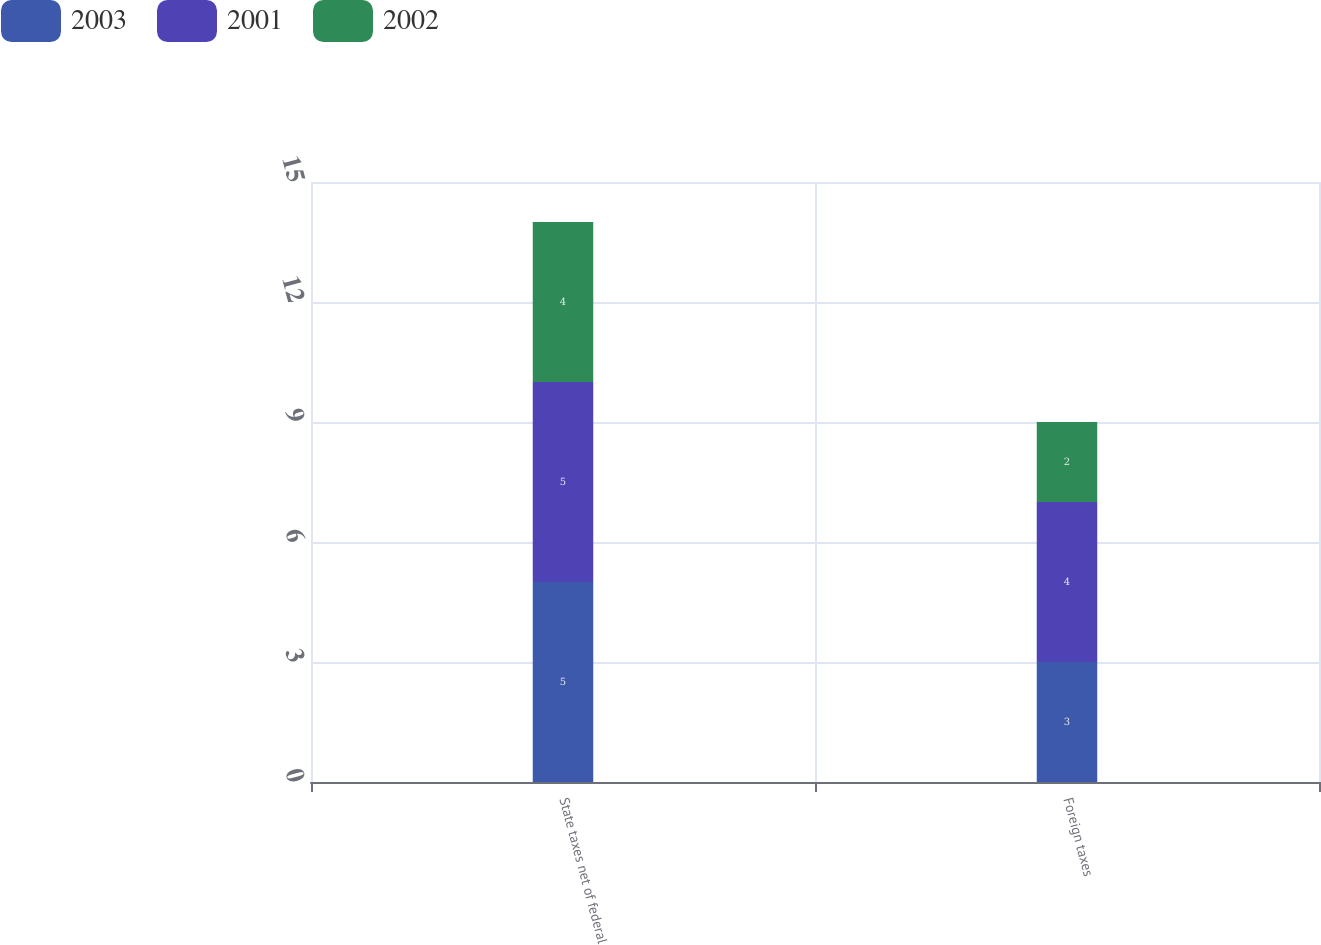Convert chart to OTSL. <chart><loc_0><loc_0><loc_500><loc_500><stacked_bar_chart><ecel><fcel>State taxes net of federal<fcel>Foreign taxes<nl><fcel>2003<fcel>5<fcel>3<nl><fcel>2001<fcel>5<fcel>4<nl><fcel>2002<fcel>4<fcel>2<nl></chart> 